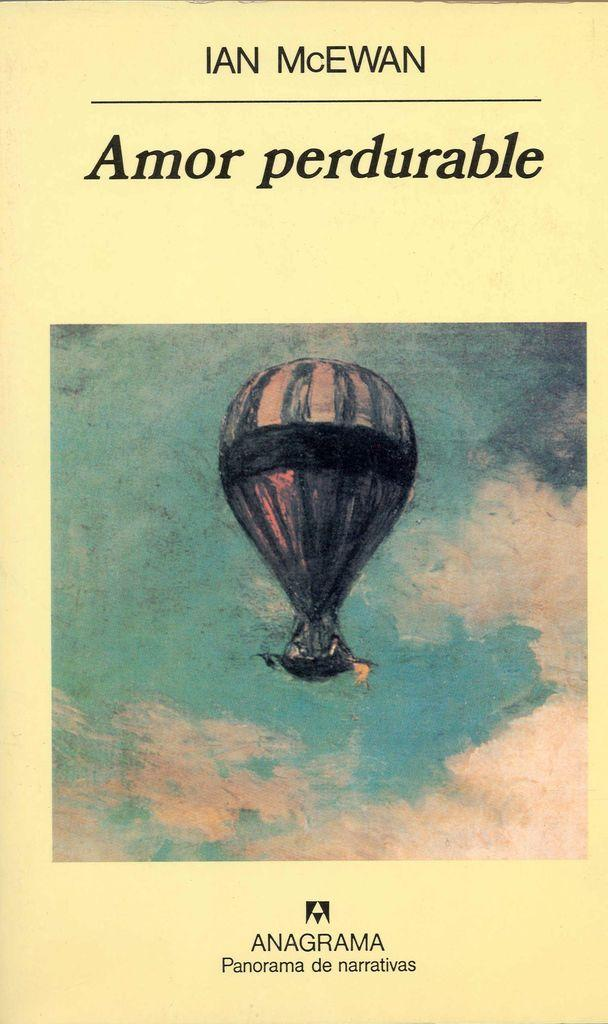What is the main subject of the image? The main subject of the image is a poster. What is depicted in the center of the poster? There is a balloon painted in the center of the poster. What information is provided at the top of the poster? There is a title at the top of the poster. Who is credited for creating the poster? The author's name is present at the bottom of the poster. How does the kitten help with the distribution of the poster in the image? There is no kitten present in the image, and therefore no such activity can be observed. 